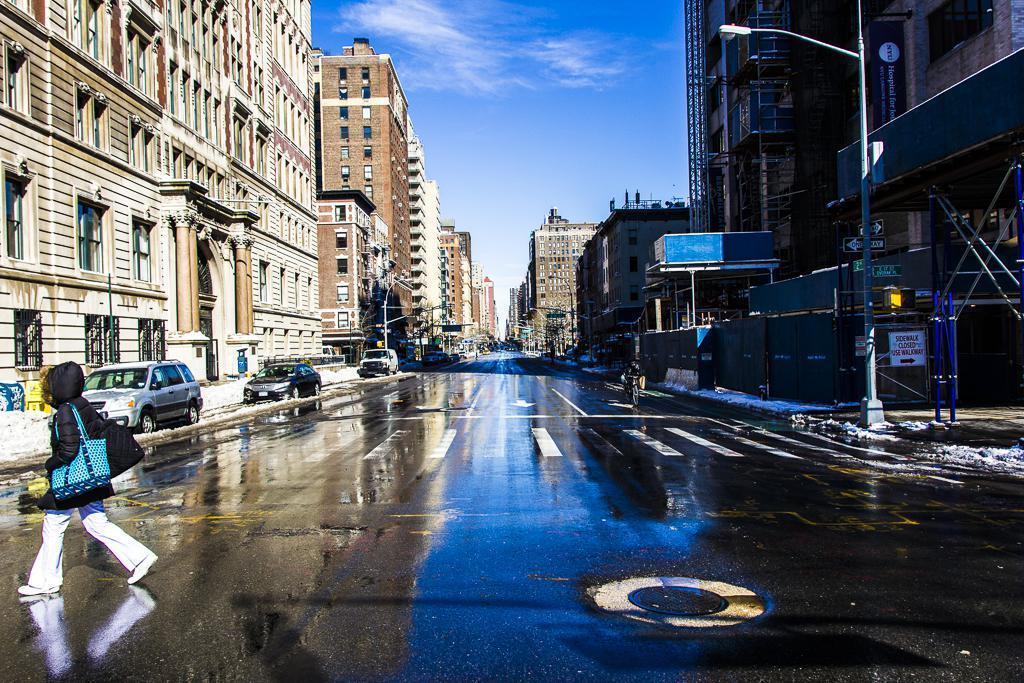How would you summarize this image in a sentence or two? In the center of the image there is a road. On the left side of the image there is a person walking on the road. There are cars. On both right and left side of the image there are buildings, street lights. In the background of the image there is sky. 